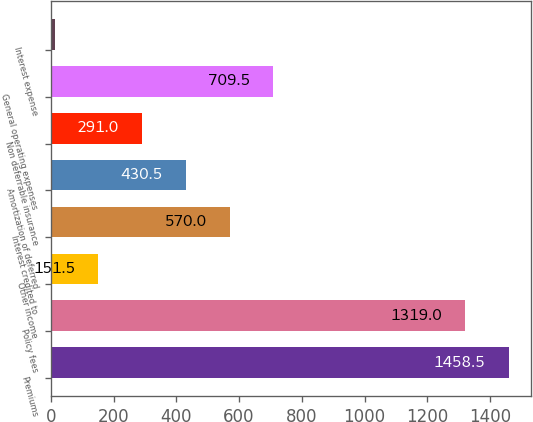<chart> <loc_0><loc_0><loc_500><loc_500><bar_chart><fcel>Premiums<fcel>Policy fees<fcel>Other income<fcel>Interest credited to<fcel>Amortization of deferred<fcel>Non deferrable insurance<fcel>General operating expenses<fcel>Interest expense<nl><fcel>1458.5<fcel>1319<fcel>151.5<fcel>570<fcel>430.5<fcel>291<fcel>709.5<fcel>12<nl></chart> 